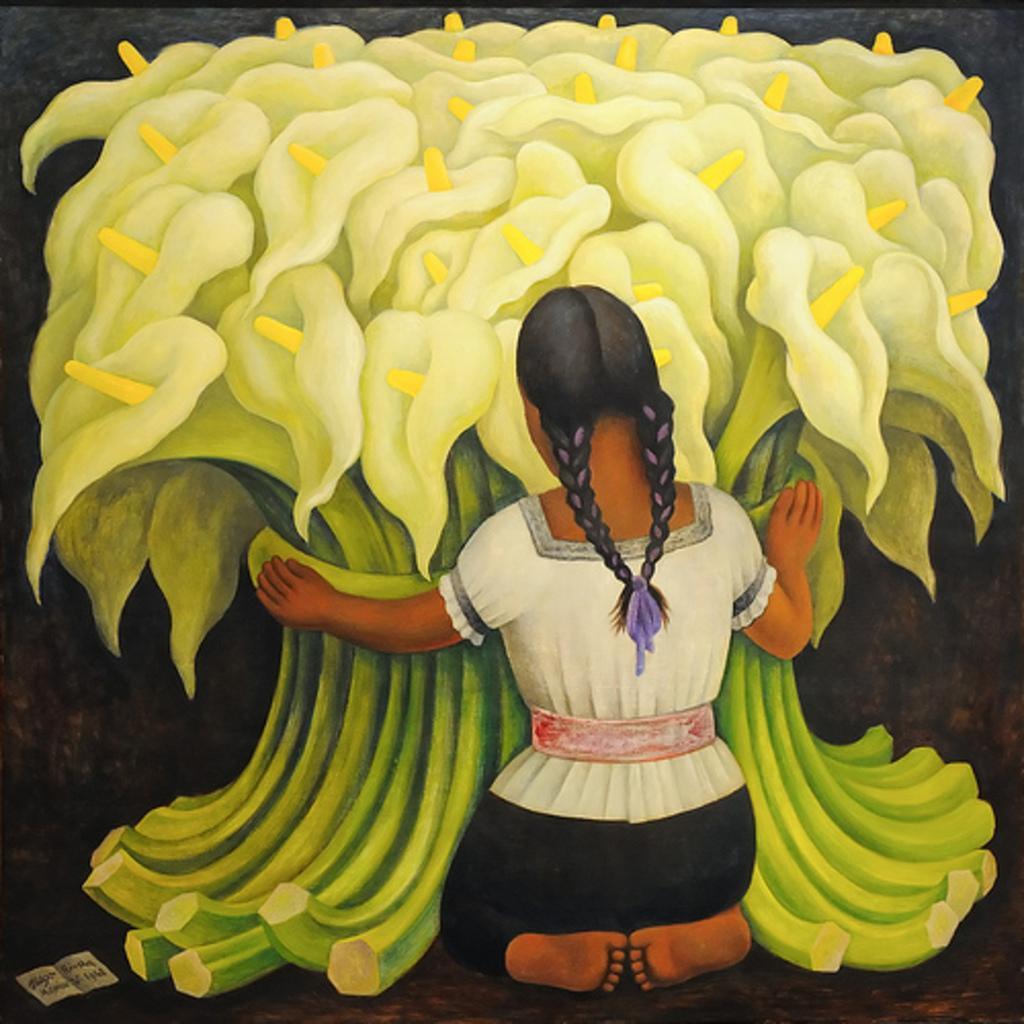Could you give a brief overview of what you see in this image? Here we can see a painting of a girl and flowers. 